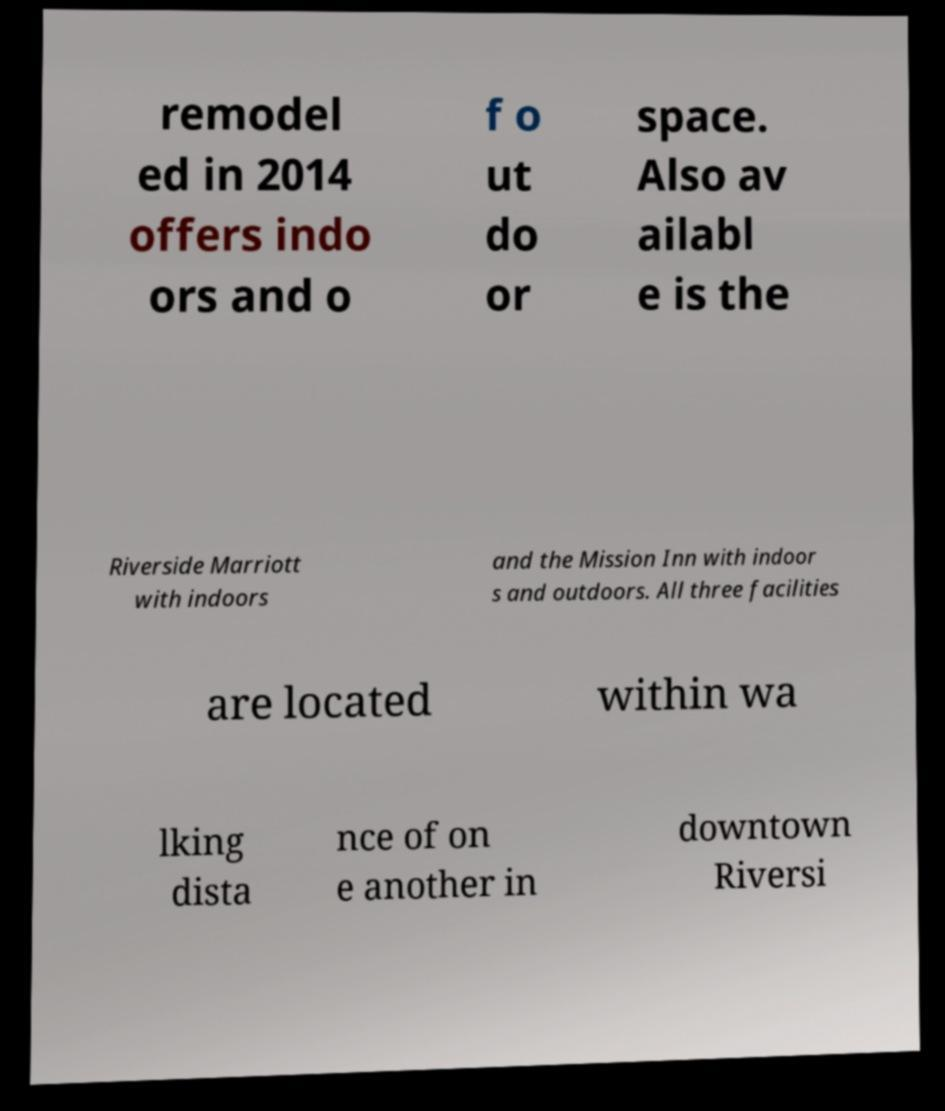For documentation purposes, I need the text within this image transcribed. Could you provide that? remodel ed in 2014 offers indo ors and o f o ut do or space. Also av ailabl e is the Riverside Marriott with indoors and the Mission Inn with indoor s and outdoors. All three facilities are located within wa lking dista nce of on e another in downtown Riversi 